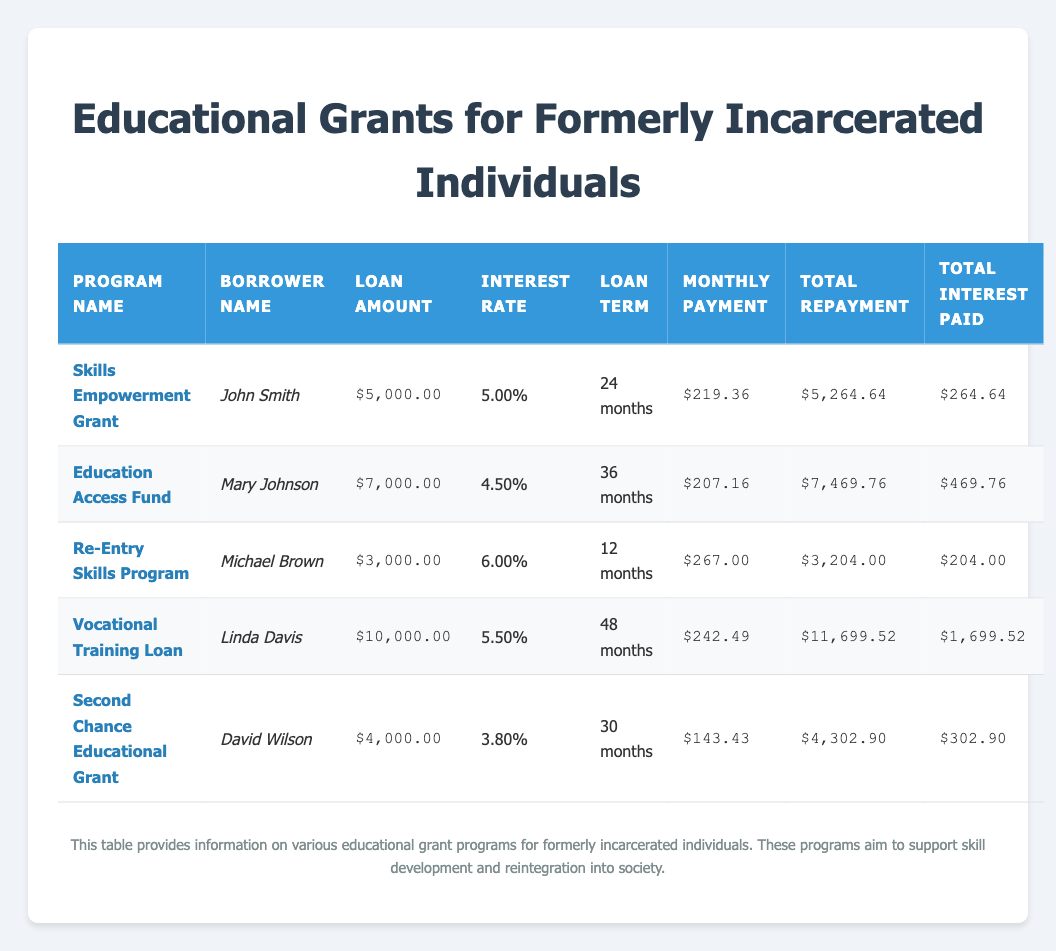What is the loan amount for the Education Access Fund? The loan amount is clearly stated in the Education Access Fund row of the table, which shows $7,000.00 for Mary Johnson.
Answer: $7,000.00 Who has the lowest total interest paid? By reviewing the total interest paid column for each borrower, Michael Brown's Re-Entry Skills Program shows the least interest at $204.00.
Answer: Michael Brown What is the total repayment amount for Linda Davis? The table lists Linda Davis's total repayment amount under the Vocational Training Loan, which is $11,699.52.
Answer: $11,699.52 What is the average monthly payment of all programs? To find the average, sum all monthly payments: (219.36 + 207.16 + 267.00 + 242.49 + 143.43) = $1,079.44; then divide by the number of programs (5). So, $1,079.44 / 5 = $215.89.
Answer: $215.89 Is the interest rate for the Second Chance Educational Grant higher than 4%? The interest rate in the table for the Second Chance Educational Grant is 3.80%, which is less than 4%, validating the statement as false.
Answer: No Which program has the highest loan amount? By checking the loan amount column, the Vocational Training Loan for Linda Davis shows the highest loan amount of $10,000.00.
Answer: $10,000.00 What is the total interest paid for Mary Johnson? The total interest paid for Mary Johnson under the Education Access Fund is listed as $469.76 in the table.
Answer: $469.76 How much more is Linda Davis's total repayment compared to Michael Brown's? Linda Davis's total repayment is $11,699.52, while Michael Brown’s total repayment is $3,204.00. The difference is $11,699.52 - $3,204.00, which equals $8,495.52.
Answer: $8,495.52 Did John Smith pay more in total repayment than Mary Johnson? John Smith's total repayment of $5,264.64 is compared against Mary Johnson's $7,469.76, which is higher, thus the answer is No.
Answer: No 